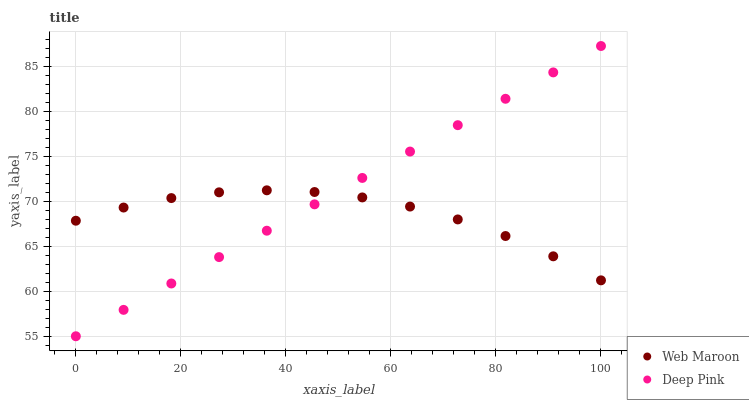Does Web Maroon have the minimum area under the curve?
Answer yes or no. Yes. Does Deep Pink have the maximum area under the curve?
Answer yes or no. Yes. Does Web Maroon have the maximum area under the curve?
Answer yes or no. No. Is Deep Pink the smoothest?
Answer yes or no. Yes. Is Web Maroon the roughest?
Answer yes or no. Yes. Is Web Maroon the smoothest?
Answer yes or no. No. Does Deep Pink have the lowest value?
Answer yes or no. Yes. Does Web Maroon have the lowest value?
Answer yes or no. No. Does Deep Pink have the highest value?
Answer yes or no. Yes. Does Web Maroon have the highest value?
Answer yes or no. No. Does Deep Pink intersect Web Maroon?
Answer yes or no. Yes. Is Deep Pink less than Web Maroon?
Answer yes or no. No. Is Deep Pink greater than Web Maroon?
Answer yes or no. No. 